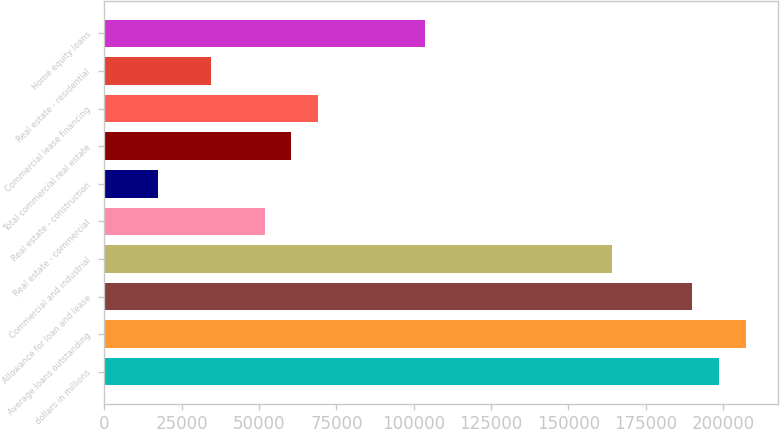Convert chart to OTSL. <chart><loc_0><loc_0><loc_500><loc_500><bar_chart><fcel>dollars in millions<fcel>Average loans outstanding<fcel>Allowance for loan and lease<fcel>Commercial and industrial<fcel>Real estate - commercial<fcel>Real estate - construction<fcel>Total commercial real estate<fcel>Commercial lease financing<fcel>Real estate - residential<fcel>Home equity loans<nl><fcel>198638<fcel>207275<fcel>190002<fcel>164093<fcel>51819.4<fcel>17273.8<fcel>60455.8<fcel>69092.2<fcel>34546.6<fcel>103638<nl></chart> 